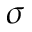Convert formula to latex. <formula><loc_0><loc_0><loc_500><loc_500>\sigma</formula> 